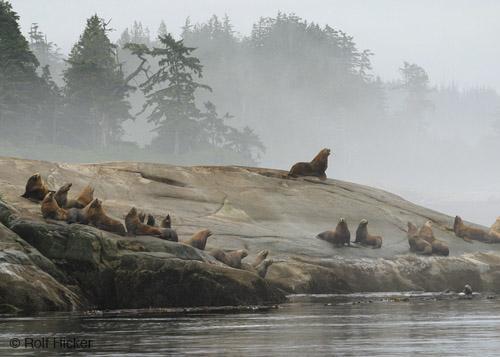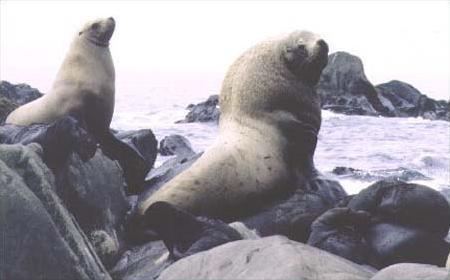The first image is the image on the left, the second image is the image on the right. Given the left and right images, does the statement "An image shows a solitary sea lion facing left." hold true? Answer yes or no. No. 